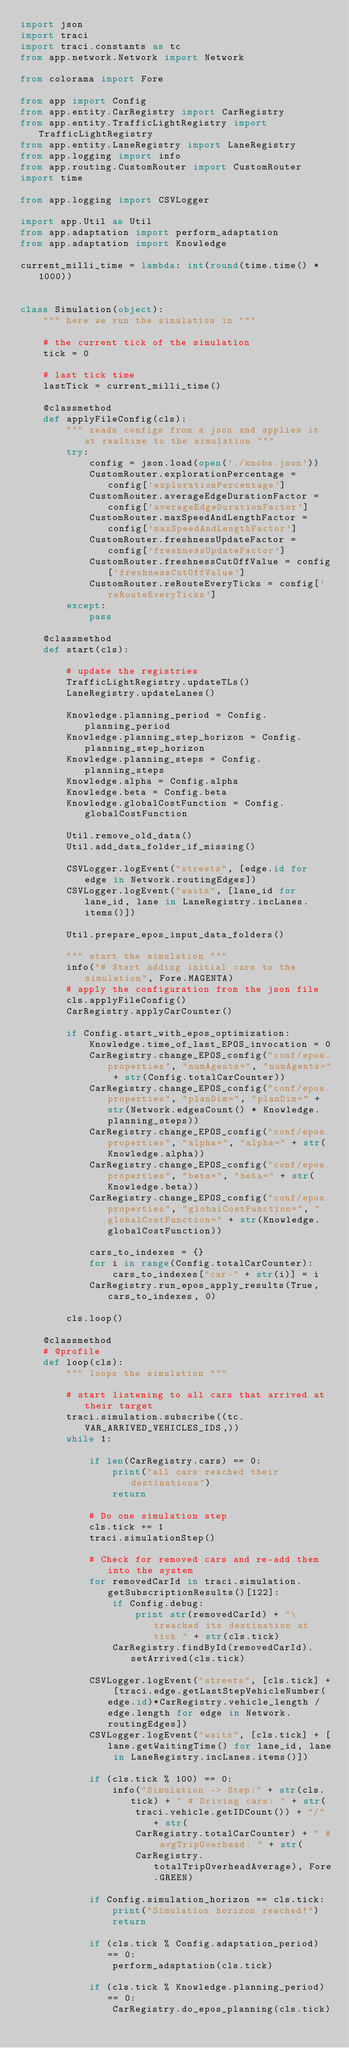<code> <loc_0><loc_0><loc_500><loc_500><_Python_>import json
import traci
import traci.constants as tc
from app.network.Network import Network

from colorama import Fore

from app import Config
from app.entity.CarRegistry import CarRegistry
from app.entity.TrafficLightRegistry import TrafficLightRegistry
from app.entity.LaneRegistry import LaneRegistry
from app.logging import info
from app.routing.CustomRouter import CustomRouter
import time

from app.logging import CSVLogger

import app.Util as Util
from app.adaptation import perform_adaptation
from app.adaptation import Knowledge

current_milli_time = lambda: int(round(time.time() * 1000))


class Simulation(object):
    """ here we run the simulation in """

    # the current tick of the simulation
    tick = 0

    # last tick time
    lastTick = current_milli_time()

    @classmethod
    def applyFileConfig(cls):
        """ reads configs from a json and applies it at realtime to the simulation """
        try:
            config = json.load(open('./knobs.json'))
            CustomRouter.explorationPercentage = config['explorationPercentage']
            CustomRouter.averageEdgeDurationFactor = config['averageEdgeDurationFactor']
            CustomRouter.maxSpeedAndLengthFactor = config['maxSpeedAndLengthFactor']
            CustomRouter.freshnessUpdateFactor = config['freshnessUpdateFactor']
            CustomRouter.freshnessCutOffValue = config['freshnessCutOffValue']
            CustomRouter.reRouteEveryTicks = config['reRouteEveryTicks']
        except:
            pass

    @classmethod
    def start(cls):

        # update the registries
        TrafficLightRegistry.updateTLs()
        LaneRegistry.updateLanes()

        Knowledge.planning_period = Config.planning_period
        Knowledge.planning_step_horizon = Config.planning_step_horizon
        Knowledge.planning_steps = Config.planning_steps
        Knowledge.alpha = Config.alpha
        Knowledge.beta = Config.beta
        Knowledge.globalCostFunction = Config.globalCostFunction

        Util.remove_old_data()
        Util.add_data_folder_if_missing()

        CSVLogger.logEvent("streets", [edge.id for edge in Network.routingEdges])
        CSVLogger.logEvent("waits", [lane_id for lane_id, lane in LaneRegistry.incLanes.items()])

        Util.prepare_epos_input_data_folders()

        """ start the simulation """
        info("# Start adding initial cars to the simulation", Fore.MAGENTA)
        # apply the configuration from the json file
        cls.applyFileConfig()
        CarRegistry.applyCarCounter()

        if Config.start_with_epos_optimization:
            Knowledge.time_of_last_EPOS_invocation = 0
            CarRegistry.change_EPOS_config("conf/epos.properties", "numAgents=", "numAgents=" + str(Config.totalCarCounter))
            CarRegistry.change_EPOS_config("conf/epos.properties", "planDim=", "planDim=" + str(Network.edgesCount() * Knowledge.planning_steps))
            CarRegistry.change_EPOS_config("conf/epos.properties", "alpha=", "alpha=" + str(Knowledge.alpha))
            CarRegistry.change_EPOS_config("conf/epos.properties", "beta=", "beta=" + str(Knowledge.beta))
            CarRegistry.change_EPOS_config("conf/epos.properties", "globalCostFunction=", "globalCostFunction=" + str(Knowledge.globalCostFunction))

            cars_to_indexes = {}
            for i in range(Config.totalCarCounter):
                cars_to_indexes["car-" + str(i)] = i
            CarRegistry.run_epos_apply_results(True, cars_to_indexes, 0)

        cls.loop()

    @classmethod
    # @profile
    def loop(cls):
        """ loops the simulation """

        # start listening to all cars that arrived at their target
        traci.simulation.subscribe((tc.VAR_ARRIVED_VEHICLES_IDS,))
        while 1:

            if len(CarRegistry.cars) == 0:
                print("all cars reached their destinations")
                return

            # Do one simulation step
            cls.tick += 1
            traci.simulationStep()

            # Check for removed cars and re-add them into the system
            for removedCarId in traci.simulation.getSubscriptionResults()[122]:
                if Config.debug:
                    print str(removedCarId) + "\treached its destination at tick " + str(cls.tick)
                CarRegistry.findById(removedCarId).setArrived(cls.tick)

            CSVLogger.logEvent("streets", [cls.tick] + [traci.edge.getLastStepVehicleNumber(edge.id)*CarRegistry.vehicle_length / edge.length for edge in Network.routingEdges])
            CSVLogger.logEvent("waits", [cls.tick] + [lane.getWaitingTime() for lane_id, lane in LaneRegistry.incLanes.items()])

            if (cls.tick % 100) == 0:
                info("Simulation -> Step:" + str(cls.tick) + " # Driving cars: " + str(
                    traci.vehicle.getIDCount()) + "/" + str(
                    CarRegistry.totalCarCounter) + " # avgTripOverhead: " + str(
                    CarRegistry.totalTripOverheadAverage), Fore.GREEN)

            if Config.simulation_horizon == cls.tick:
                print("Simulation horizon reached!")
                return

            if (cls.tick % Config.adaptation_period) == 0:
                perform_adaptation(cls.tick)

            if (cls.tick % Knowledge.planning_period) == 0:
                CarRegistry.do_epos_planning(cls.tick)</code> 